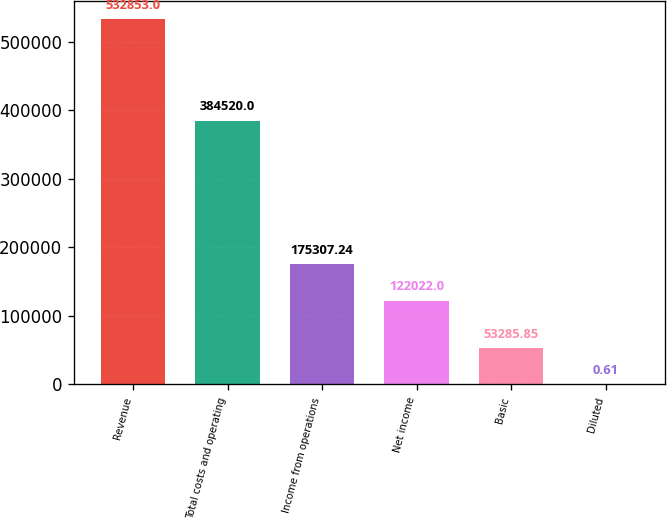Convert chart. <chart><loc_0><loc_0><loc_500><loc_500><bar_chart><fcel>Revenue<fcel>Total costs and operating<fcel>Income from operations<fcel>Net income<fcel>Basic<fcel>Diluted<nl><fcel>532853<fcel>384520<fcel>175307<fcel>122022<fcel>53285.8<fcel>0.61<nl></chart> 